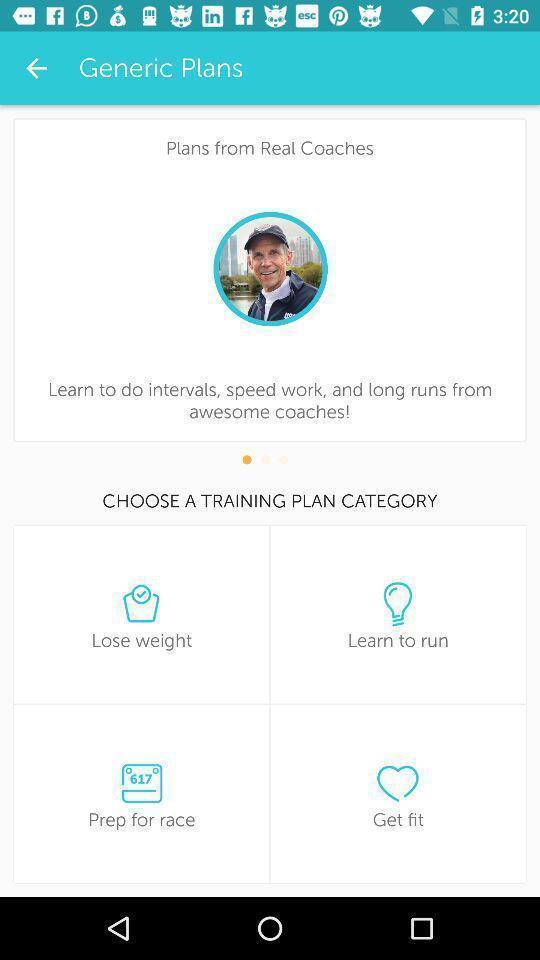Describe this image in words. Screen displaying the page of a fitness app. 